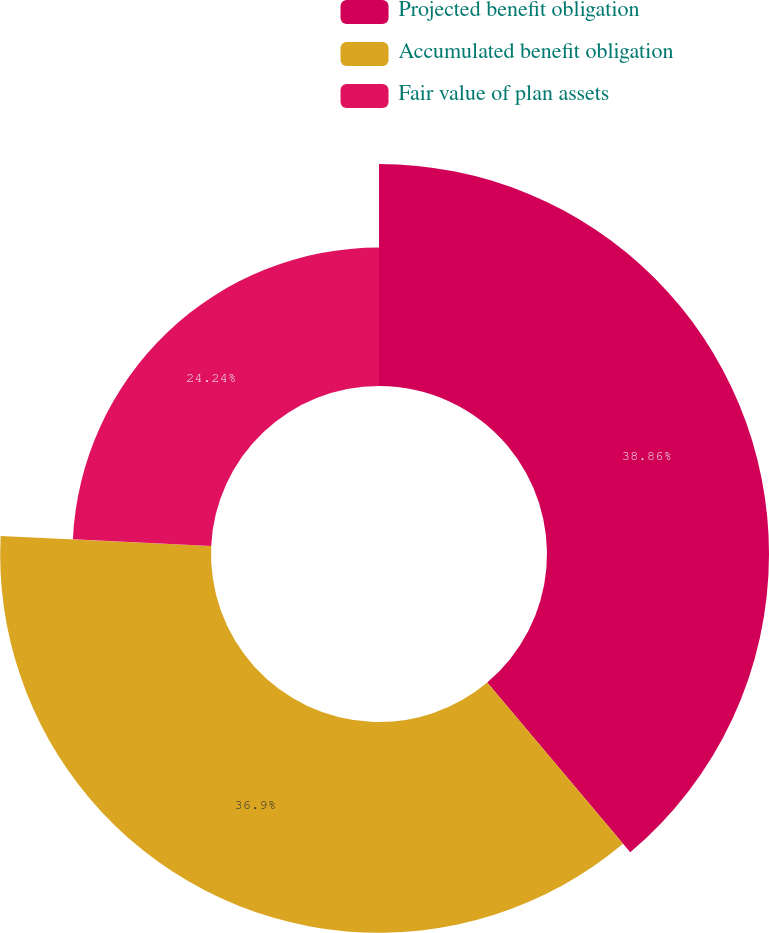Convert chart. <chart><loc_0><loc_0><loc_500><loc_500><pie_chart><fcel>Projected benefit obligation<fcel>Accumulated benefit obligation<fcel>Fair value of plan assets<nl><fcel>38.86%<fcel>36.9%<fcel>24.24%<nl></chart> 